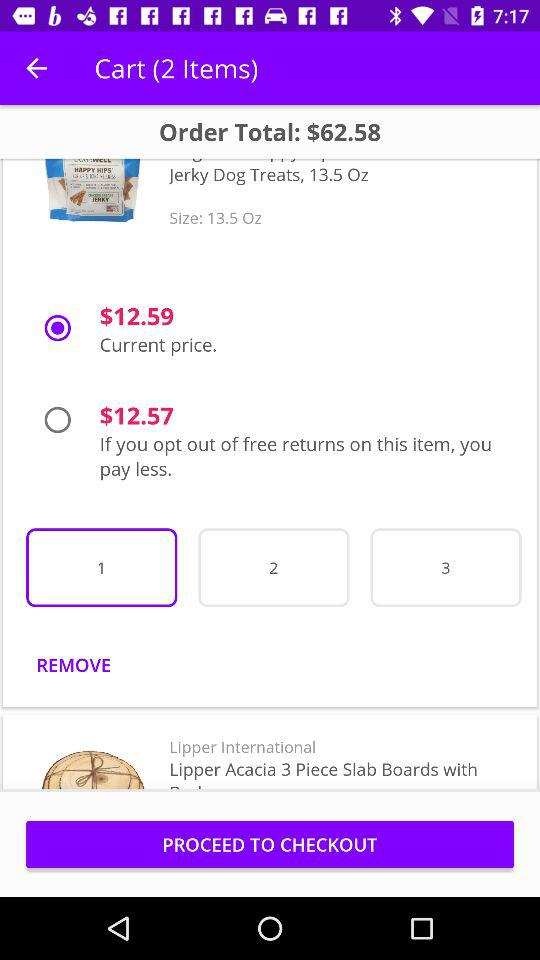What's the size of the product? The size of the product is 13.5 oz. 